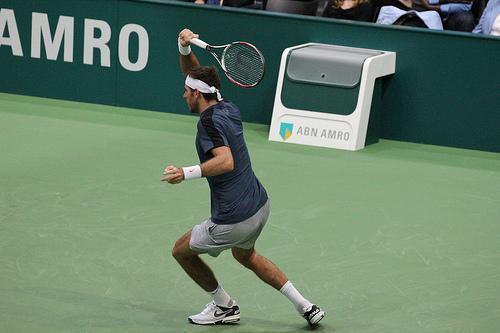How many people are clearly seen?
Give a very brief answer. 1. 